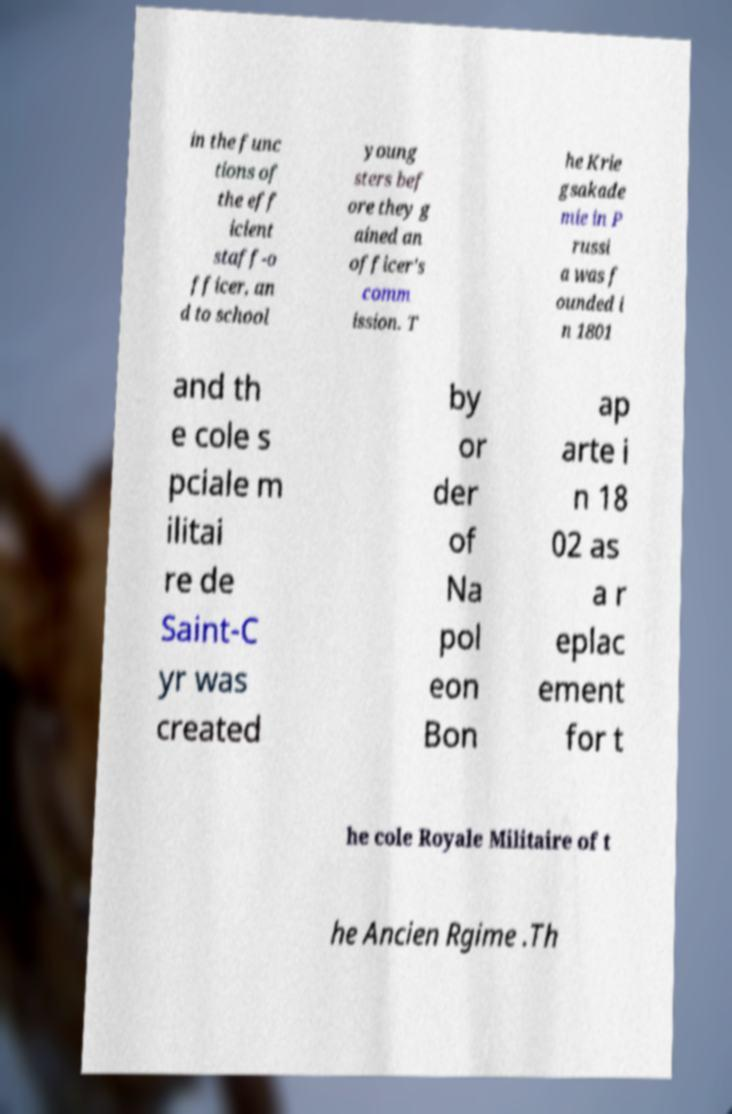There's text embedded in this image that I need extracted. Can you transcribe it verbatim? in the func tions of the eff icient staff-o fficer, an d to school young sters bef ore they g ained an officer's comm ission. T he Krie gsakade mie in P russi a was f ounded i n 1801 and th e cole s pciale m ilitai re de Saint-C yr was created by or der of Na pol eon Bon ap arte i n 18 02 as a r eplac ement for t he cole Royale Militaire of t he Ancien Rgime .Th 